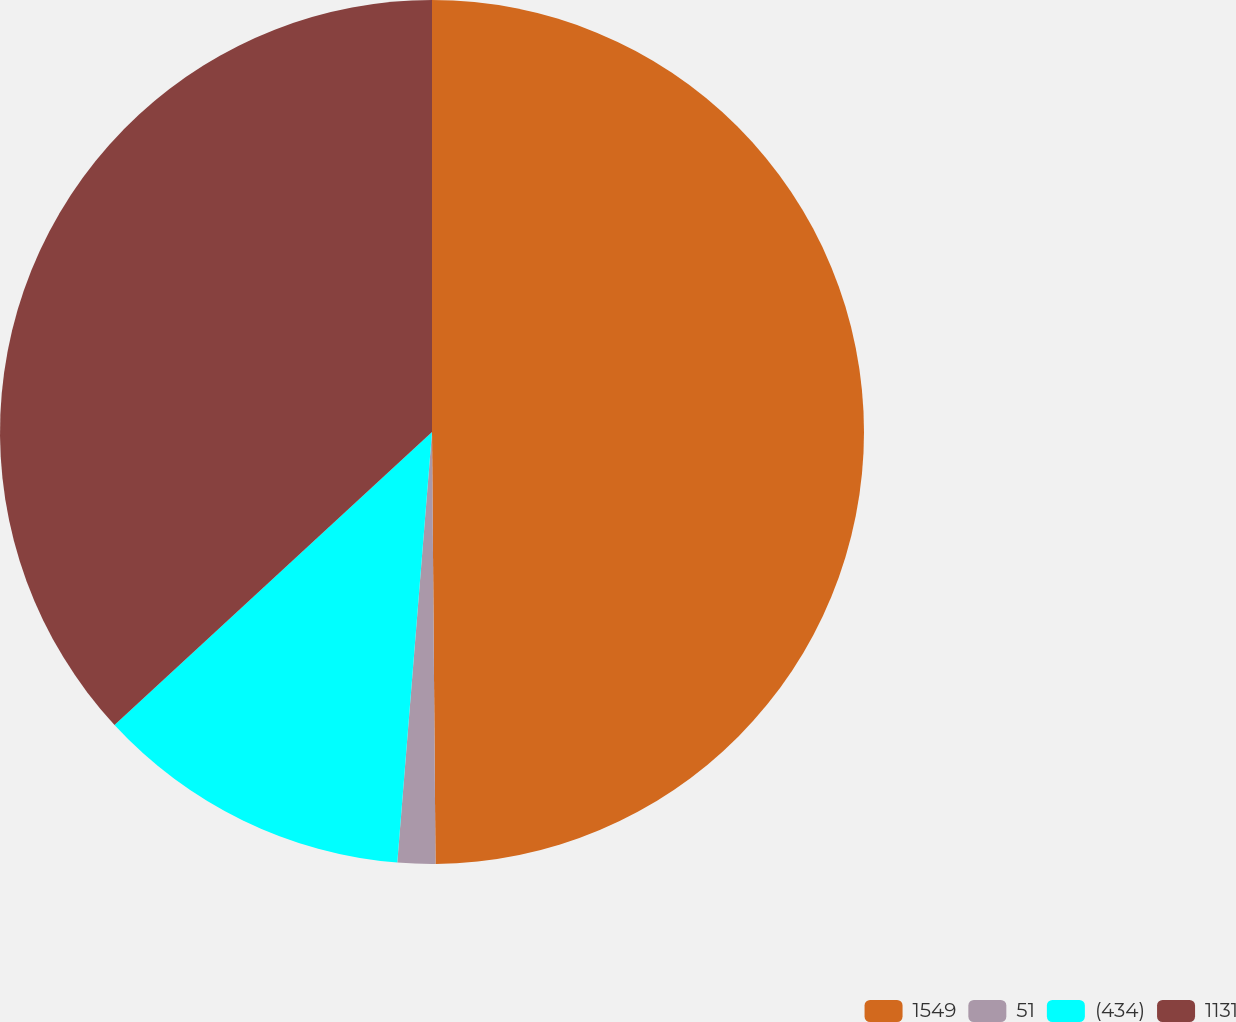<chart> <loc_0><loc_0><loc_500><loc_500><pie_chart><fcel>1549<fcel>51<fcel>(434)<fcel>1131<nl><fcel>49.87%<fcel>1.41%<fcel>11.86%<fcel>36.86%<nl></chart> 